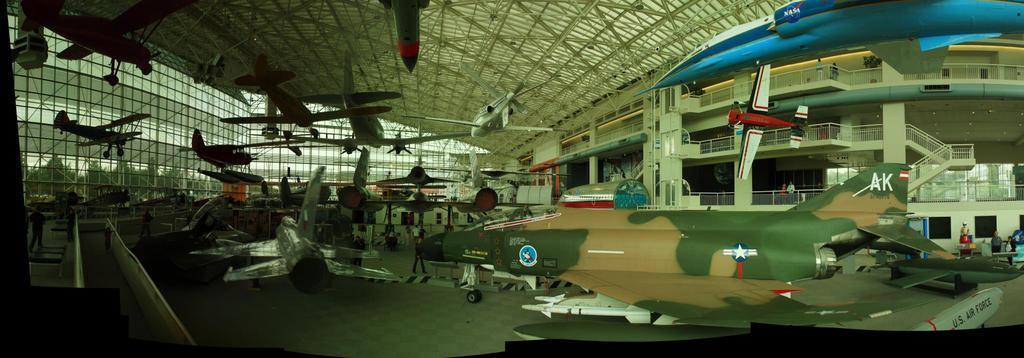In one or two sentences, can you explain what this image depicts? In this image, there are a few aircrafts, people. We can see the fence and the ground. We can see some stairs and the railing. We can also see some objects and the shed at the top. 